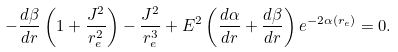Convert formula to latex. <formula><loc_0><loc_0><loc_500><loc_500>- \frac { d \beta } { d r } \left ( 1 + \frac { J ^ { 2 } } { r _ { e } ^ { 2 } } \right ) - \frac { J ^ { 2 } } { r _ { e } ^ { 3 } } + E ^ { 2 } \left ( \frac { d \alpha } { d r } + \frac { d \beta } { d r } \right ) e ^ { - 2 \alpha ( r _ { e } ) } = 0 .</formula> 